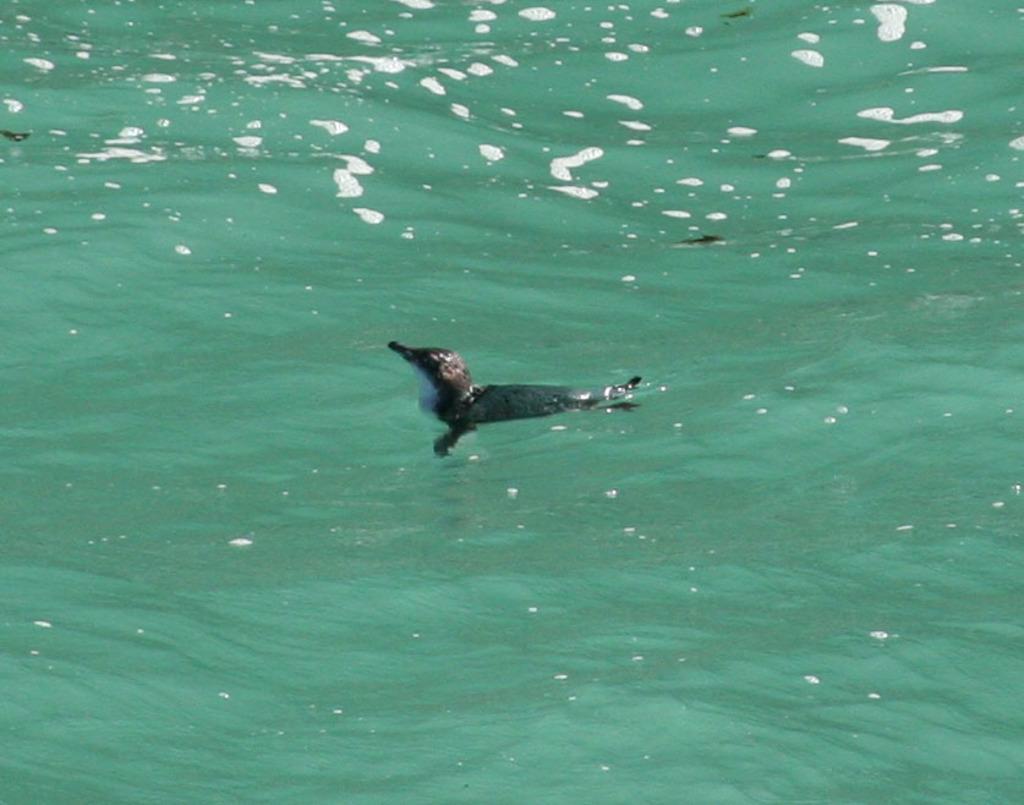Please provide a concise description of this image. In this image I can see water and in the centre of this image I can see a bird on the water. 